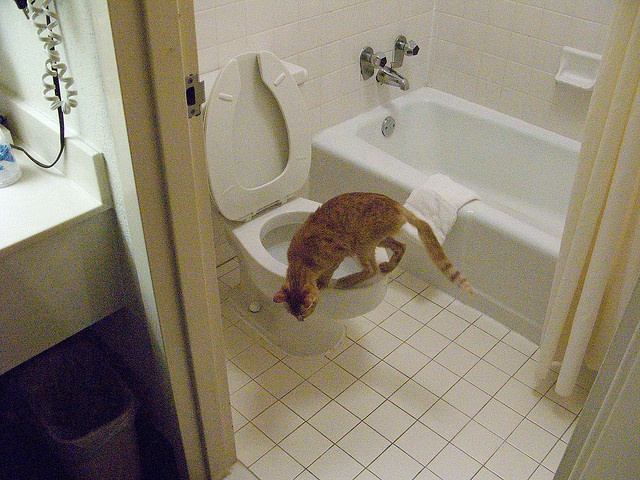Describe the objects in this image and their specific colors. I can see toilet in darkgray, tan, and gray tones and cat in darkgray, olive, maroon, black, and brown tones in this image. 